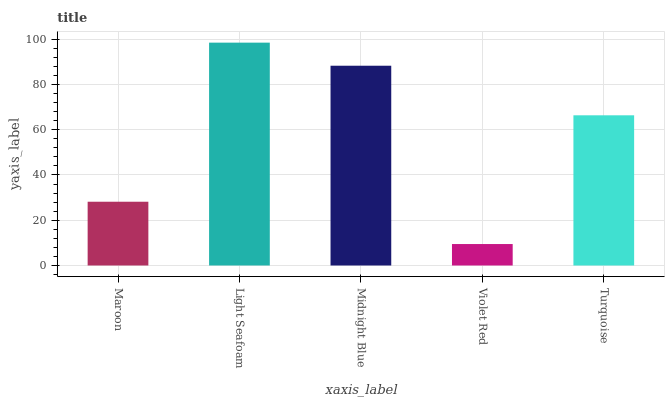Is Midnight Blue the minimum?
Answer yes or no. No. Is Midnight Blue the maximum?
Answer yes or no. No. Is Light Seafoam greater than Midnight Blue?
Answer yes or no. Yes. Is Midnight Blue less than Light Seafoam?
Answer yes or no. Yes. Is Midnight Blue greater than Light Seafoam?
Answer yes or no. No. Is Light Seafoam less than Midnight Blue?
Answer yes or no. No. Is Turquoise the high median?
Answer yes or no. Yes. Is Turquoise the low median?
Answer yes or no. Yes. Is Midnight Blue the high median?
Answer yes or no. No. Is Violet Red the low median?
Answer yes or no. No. 